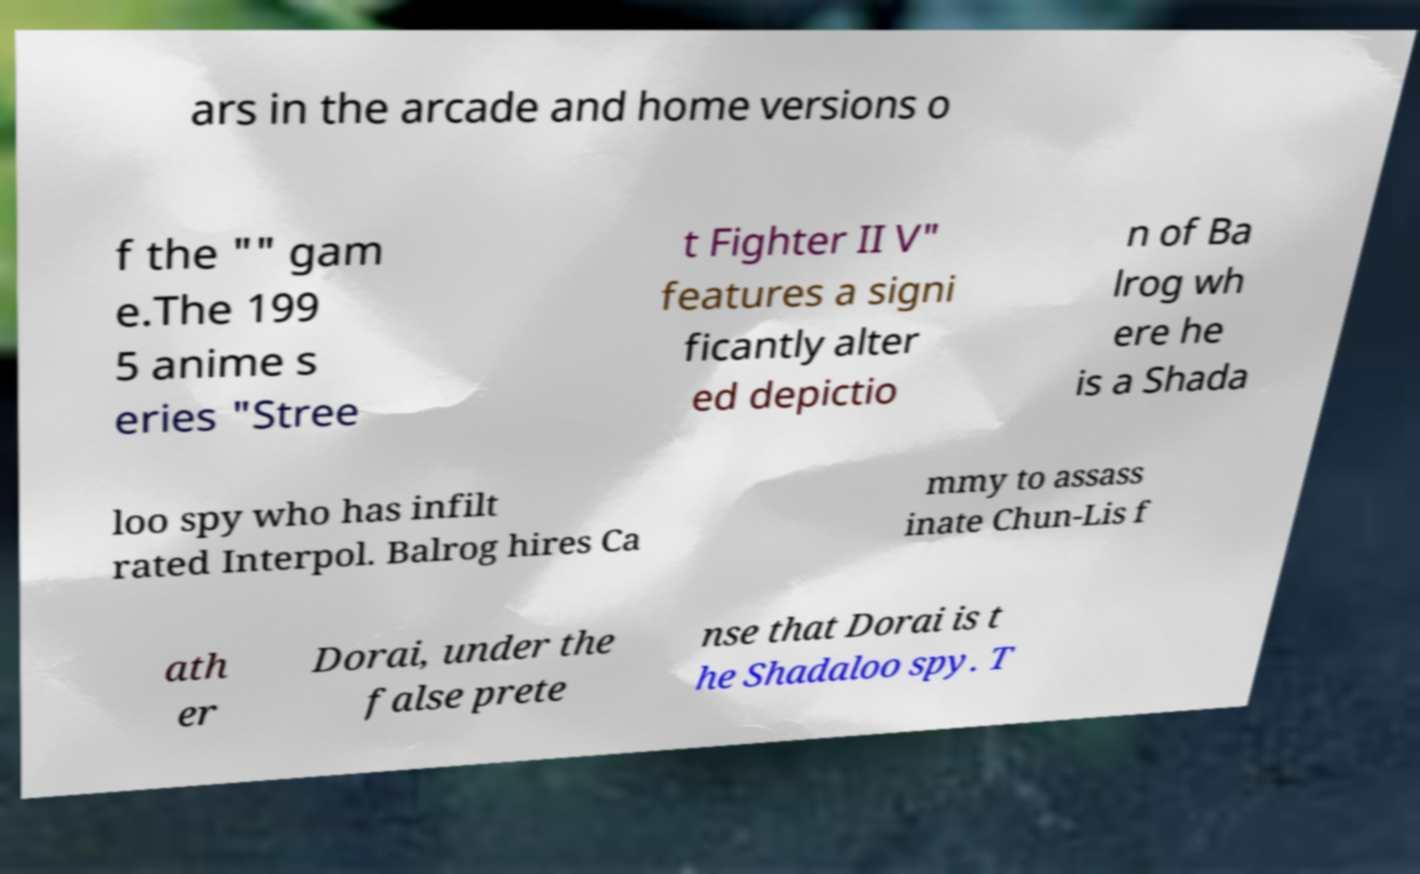Can you read and provide the text displayed in the image?This photo seems to have some interesting text. Can you extract and type it out for me? ars in the arcade and home versions o f the "" gam e.The 199 5 anime s eries "Stree t Fighter II V" features a signi ficantly alter ed depictio n of Ba lrog wh ere he is a Shada loo spy who has infilt rated Interpol. Balrog hires Ca mmy to assass inate Chun-Lis f ath er Dorai, under the false prete nse that Dorai is t he Shadaloo spy. T 